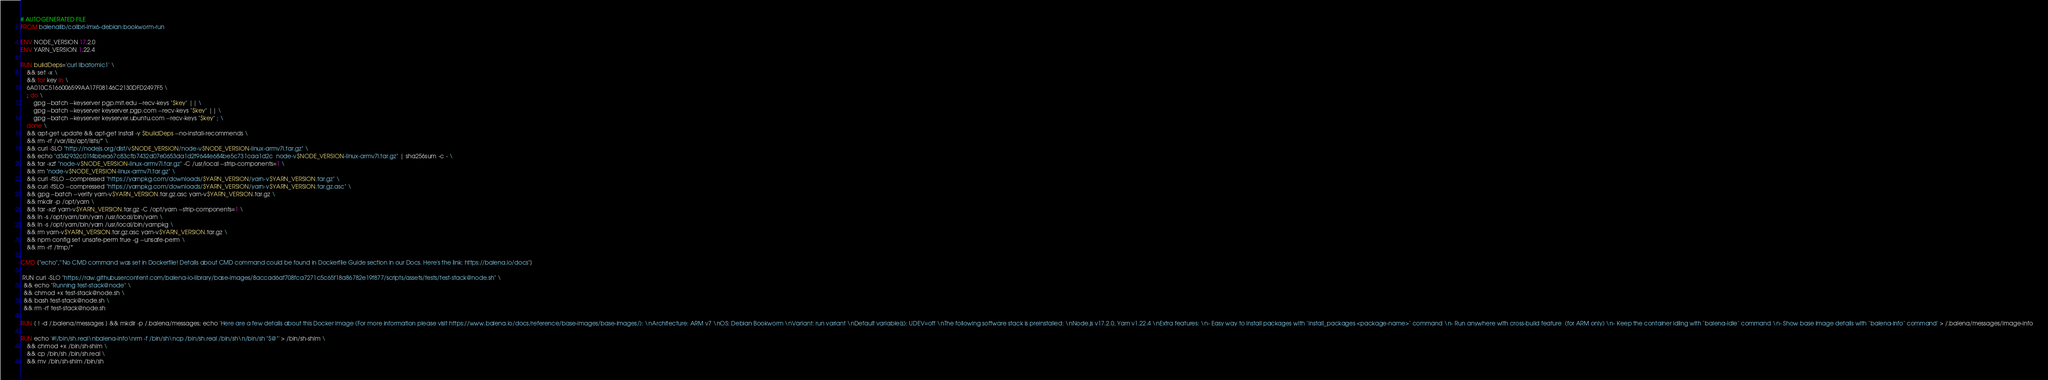Convert code to text. <code><loc_0><loc_0><loc_500><loc_500><_Dockerfile_># AUTOGENERATED FILE
FROM balenalib/colibri-imx6-debian:bookworm-run

ENV NODE_VERSION 17.2.0
ENV YARN_VERSION 1.22.4

RUN buildDeps='curl libatomic1' \
	&& set -x \
	&& for key in \
	6A010C5166006599AA17F08146C2130DFD2497F5 \
	; do \
		gpg --batch --keyserver pgp.mit.edu --recv-keys "$key" || \
		gpg --batch --keyserver keyserver.pgp.com --recv-keys "$key" || \
		gpg --batch --keyserver keyserver.ubuntu.com --recv-keys "$key" ; \
	done \
	&& apt-get update && apt-get install -y $buildDeps --no-install-recommends \
	&& rm -rf /var/lib/apt/lists/* \
	&& curl -SLO "http://nodejs.org/dist/v$NODE_VERSION/node-v$NODE_VERSION-linux-armv7l.tar.gz" \
	&& echo "d342932c01f4bbea67c83cfb7432d07e0653da1d2f9644e684be5c731caa1d2c  node-v$NODE_VERSION-linux-armv7l.tar.gz" | sha256sum -c - \
	&& tar -xzf "node-v$NODE_VERSION-linux-armv7l.tar.gz" -C /usr/local --strip-components=1 \
	&& rm "node-v$NODE_VERSION-linux-armv7l.tar.gz" \
	&& curl -fSLO --compressed "https://yarnpkg.com/downloads/$YARN_VERSION/yarn-v$YARN_VERSION.tar.gz" \
	&& curl -fSLO --compressed "https://yarnpkg.com/downloads/$YARN_VERSION/yarn-v$YARN_VERSION.tar.gz.asc" \
	&& gpg --batch --verify yarn-v$YARN_VERSION.tar.gz.asc yarn-v$YARN_VERSION.tar.gz \
	&& mkdir -p /opt/yarn \
	&& tar -xzf yarn-v$YARN_VERSION.tar.gz -C /opt/yarn --strip-components=1 \
	&& ln -s /opt/yarn/bin/yarn /usr/local/bin/yarn \
	&& ln -s /opt/yarn/bin/yarn /usr/local/bin/yarnpkg \
	&& rm yarn-v$YARN_VERSION.tar.gz.asc yarn-v$YARN_VERSION.tar.gz \
	&& npm config set unsafe-perm true -g --unsafe-perm \
	&& rm -rf /tmp/*

CMD ["echo","'No CMD command was set in Dockerfile! Details about CMD command could be found in Dockerfile Guide section in our Docs. Here's the link: https://balena.io/docs"]

 RUN curl -SLO "https://raw.githubusercontent.com/balena-io-library/base-images/8accad6af708fca7271c5c65f18a86782e19f877/scripts/assets/tests/test-stack@node.sh" \
  && echo "Running test-stack@node" \
  && chmod +x test-stack@node.sh \
  && bash test-stack@node.sh \
  && rm -rf test-stack@node.sh 

RUN [ ! -d /.balena/messages ] && mkdir -p /.balena/messages; echo 'Here are a few details about this Docker image (For more information please visit https://www.balena.io/docs/reference/base-images/base-images/): \nArchitecture: ARM v7 \nOS: Debian Bookworm \nVariant: run variant \nDefault variable(s): UDEV=off \nThe following software stack is preinstalled: \nNode.js v17.2.0, Yarn v1.22.4 \nExtra features: \n- Easy way to install packages with `install_packages <package-name>` command \n- Run anywhere with cross-build feature  (for ARM only) \n- Keep the container idling with `balena-idle` command \n- Show base image details with `balena-info` command' > /.balena/messages/image-info

RUN echo '#!/bin/sh.real\nbalena-info\nrm -f /bin/sh\ncp /bin/sh.real /bin/sh\n/bin/sh "$@"' > /bin/sh-shim \
	&& chmod +x /bin/sh-shim \
	&& cp /bin/sh /bin/sh.real \
	&& mv /bin/sh-shim /bin/sh</code> 